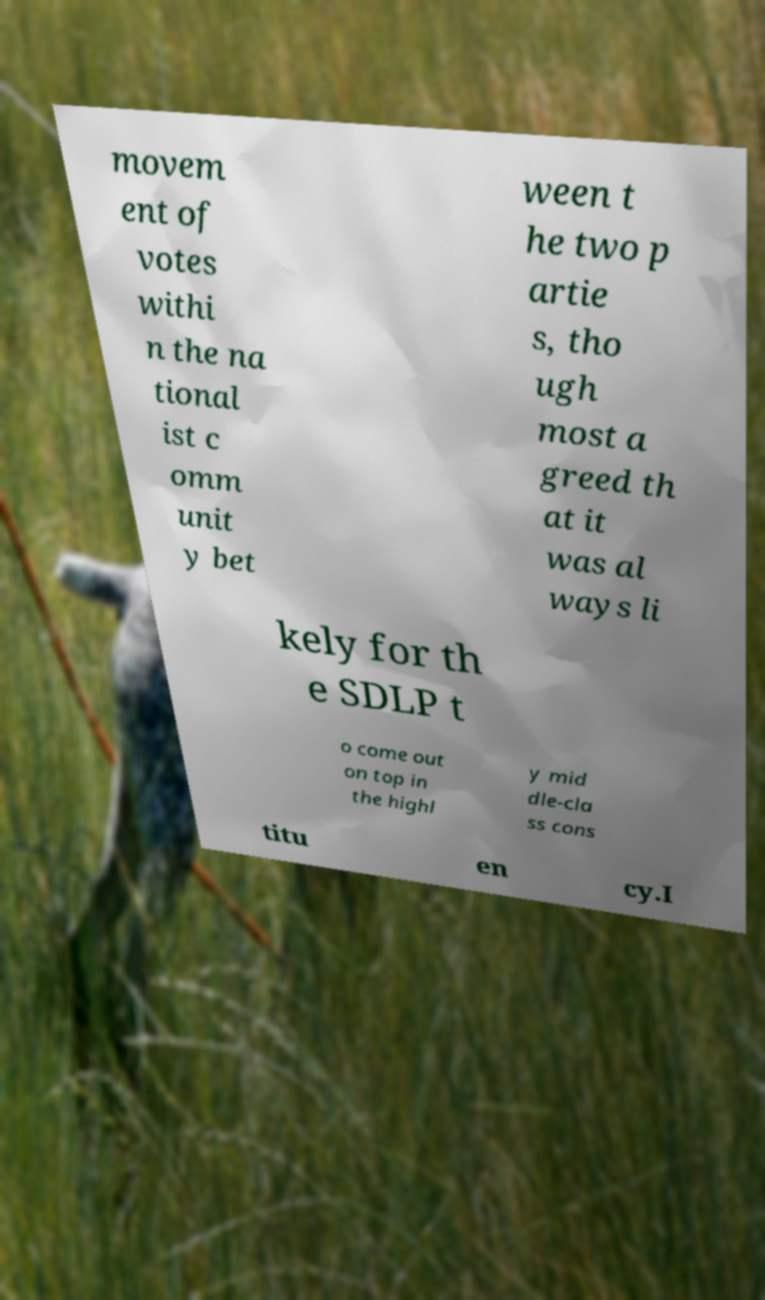Could you extract and type out the text from this image? movem ent of votes withi n the na tional ist c omm unit y bet ween t he two p artie s, tho ugh most a greed th at it was al ways li kely for th e SDLP t o come out on top in the highl y mid dle-cla ss cons titu en cy.I 